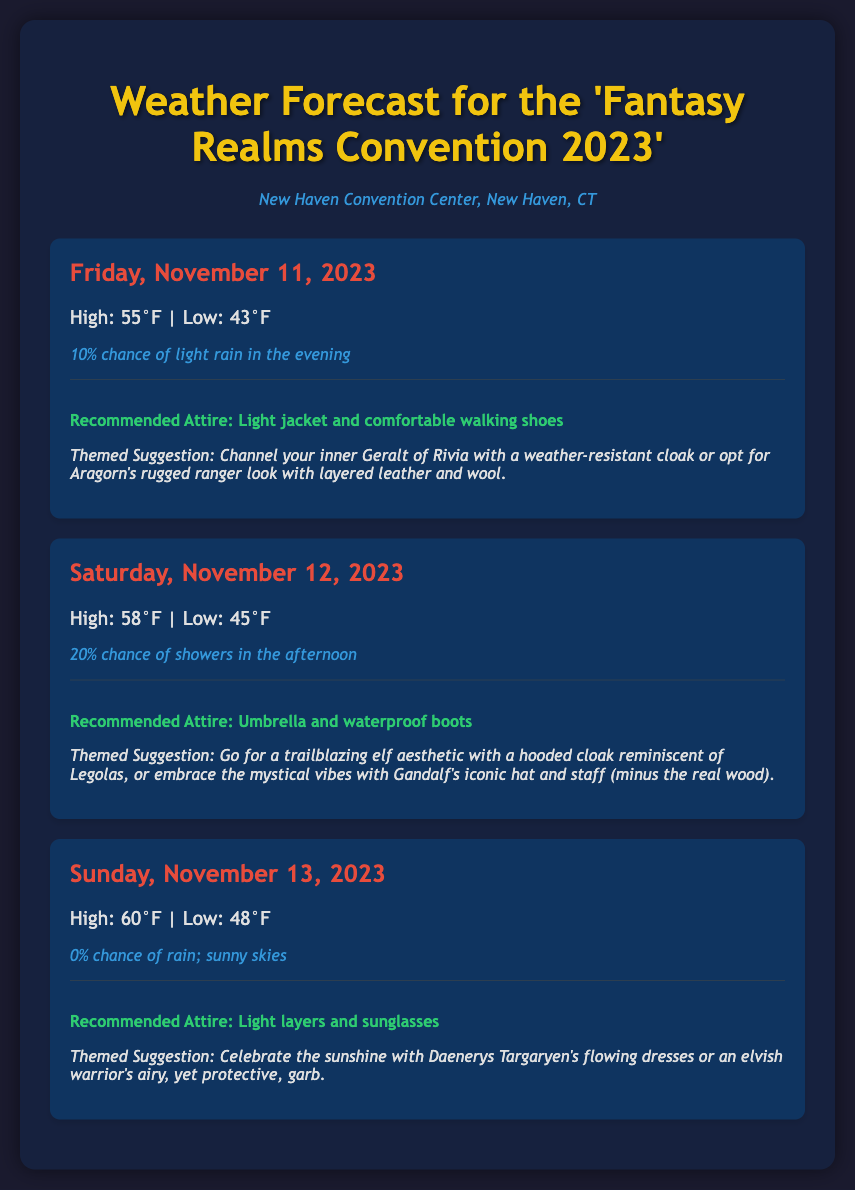What is the location of the convention? The location is specified in the document, indicating the address for the event.
Answer: New Haven Convention Center, New Haven, CT What is the high temperature on Saturday, November 12, 2023? The document provides specific high and low temperatures for each day of the convention.
Answer: 58°F What is the chance of precipitation on Sunday, November 13, 2023? The document lists the chance of rain for each day, with specifics given for Sunday.
Answer: 0% What themed attire suggestion is given for Friday? The document includes a themed attire suggestion for each day, specifically mentioning notable characters.
Answer: Geralt of Rivia or Aragorn What is the recommended attire for Saturday? Each day has a section detailing recommended attire based on weather conditions.
Answer: Umbrella and waterproof boots What day has the highest expected temperature? The temperatures for each day are compared to determine the highest.
Answer: Sunday What is the expected weather condition for Sunday? The document outlines whether rain is expected and the general weather conditions for each day.
Answer: Sunny skies How many days are covered in the weather forecast? The document outlines the weather for each day of the convention in total.
Answer: Three days What specific outfit is suggested for sunny weather on Sunday? Each day's attire recommendations include specific character references or themes suited for the weather.
Answer: Daenerys Targaryen's flowing dresses 